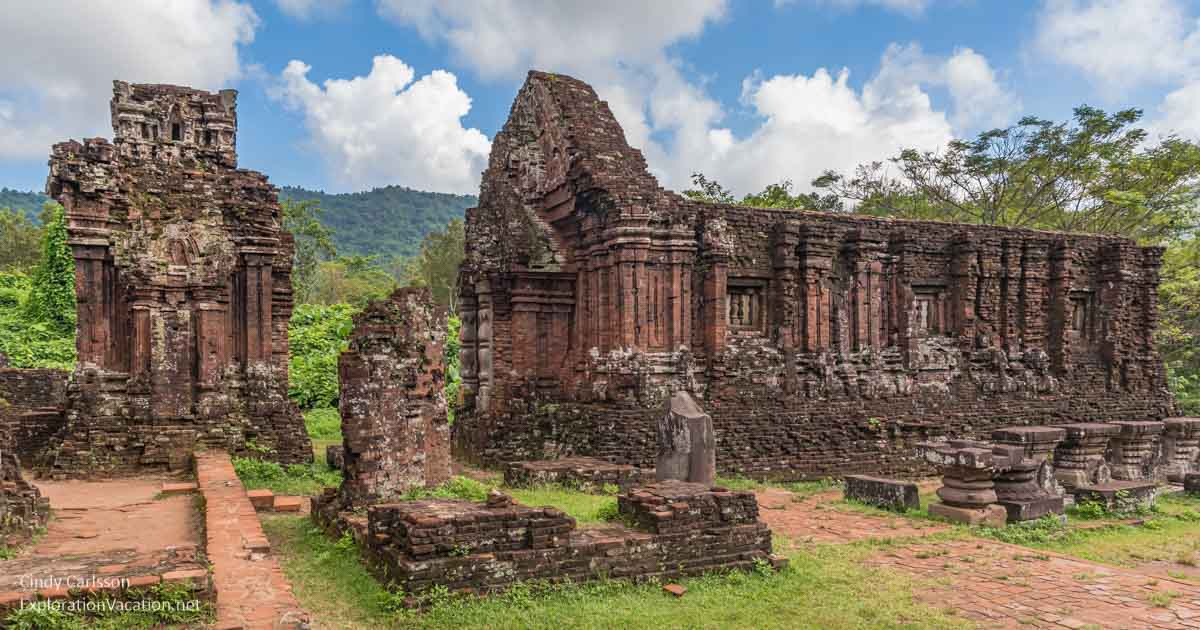How does the natural landscape around the ruins enhance the overall ambiance? The natural landscape surrounding the ruins of the My Son temple complex greatly enhances the overall ambiance, creating a serene and almost mystical atmosphere. The lush greenery enveloping the ancient structures provides a striking contrast against the red bricks, emphasizing the passage of time and nature's reclaiming presence. The surrounding mountains add a sense of grandeur and protection, as if they stand as silent guardians of the historical site. This blend of natural and man-made beauty fosters a contemplative and awe-inspiring environment, inviting visitors to reflect on the intertwining of human history and the natural world. Do you think the site would feel the sharegpt4v/same without the mountains and greenery? Without the mountains and greenery, the My Son temple complex would lose much of its enchanting allure. The natural elements contribute significantly to its visual and emotional impact, providing a vivid backdrop that enhances the aesthetic appeal and evokes a sense of timelessness. The greenery symbolizes life and renewal, juxtaposed against the ancient ruins, which signify history and endurance. The mountains, on the other hand, add a majestic scale and a feeling of protection. Without these elements, the site might feel more stark and less imbued with the profound sense of connection between nature and historical legacy. 